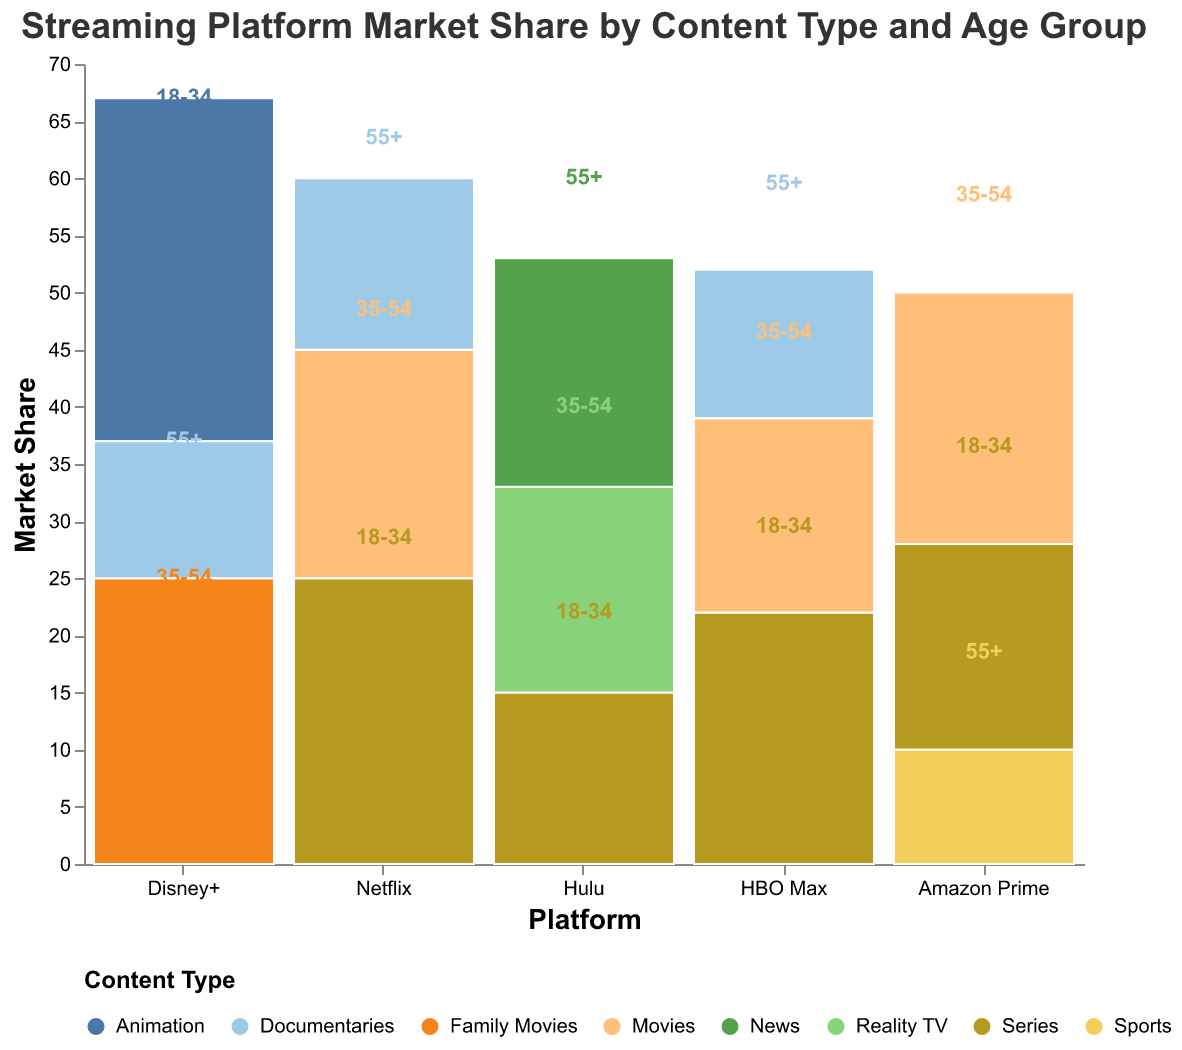What is the title of the figure? The title of the figure is located at the top of the chart and describes the content of the visualization.
Answer: Streaming Platform Market Share by Content Type and Age Group Which streaming platform has the highest market share for the 18-34 age group? Look at the bars within the 18-34 age group and identify the platform with the highest market share for that age group.
Answer: Disney+ How many different content types are shown in the mosaic plot? Count the distinct categories of content type represented by different colors in the legend.
Answer: 8 What is the total market share for Netflix? Sum up the market shares for all content types and age groups for Netflix.
Answer: 60 Which platform has the least market share in the 55+ age group? Compare the market shares for all platforms within the 55+ age group and identify the smallest value.
Answer: Amazon Prime What is the difference in market share between Hulu and HBO Max for the 18-34 age group? Identify the market shares for Hulu and HBO Max for the 18-34 age group and calculate the difference.
Answer: 7 What is the market share of documentaries across all platforms combined? Sum up the market shares of documentaries from Netflix, Disney+, and HBO Max.
Answer: 40 Which content type has the highest total market share across all age groups and platforms? Add up the market shares for each content type across all age groups and platforms and compare the totals.
Answer: Series How does the market share of Amazon Prime for the 35-54 age group compare to that of Netflix for the same age group? Look at the market share values for Amazon Prime and Netflix within the 35-54 age group and compare them.
Answer: Amazon Prime has a higher market share What is the combined market share of Disney+ for the 35-54 and 55+ age groups? Sum the market shares of Disney+ for the 35-54 and 55+ age groups.
Answer: 37 